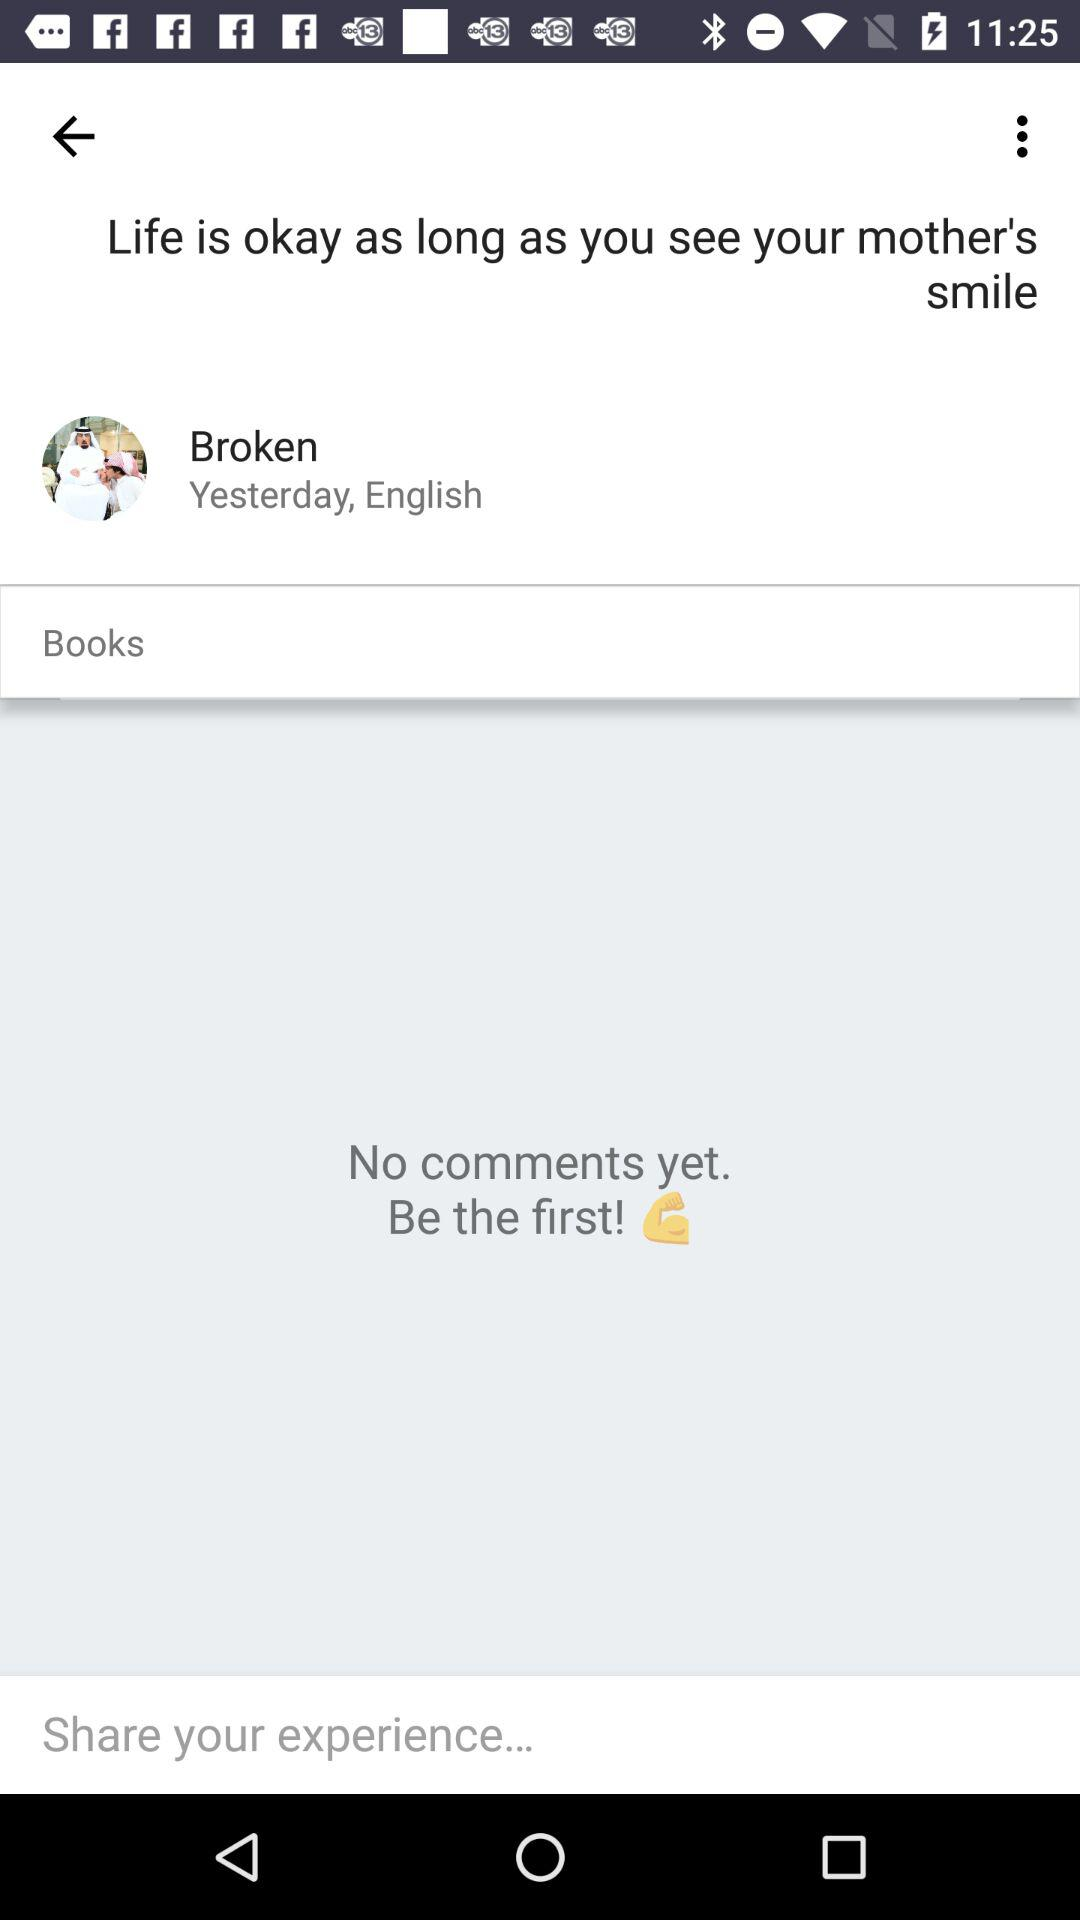When did Broken update a post? Broken updated the post yesterday. 